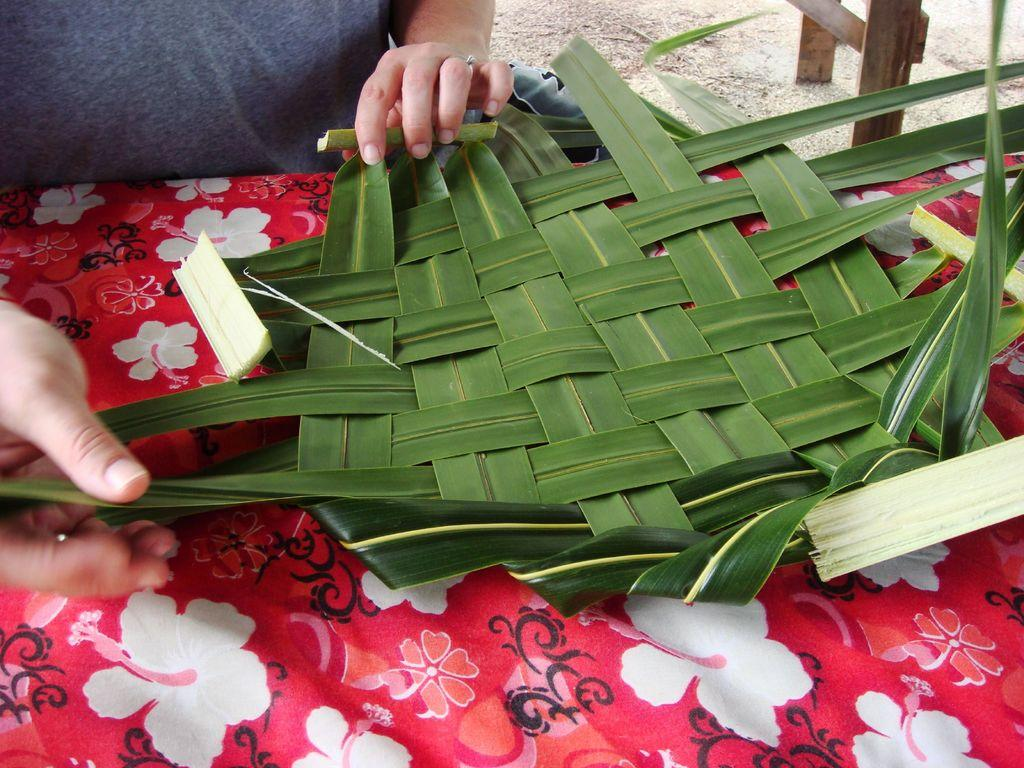What is the main subject of the image? There is a human in the image. What is the human holding in the image? The human is holding leaves in the image. Where are the leaves located in the image? The leaves are on a table in the image. What is the color of the cloth on the table? There is a pink color cloth on the table in the image. What type of industry is depicted in the image? There is no industry depicted in the image; it features a human holding leaves on a table with a pink cloth. 